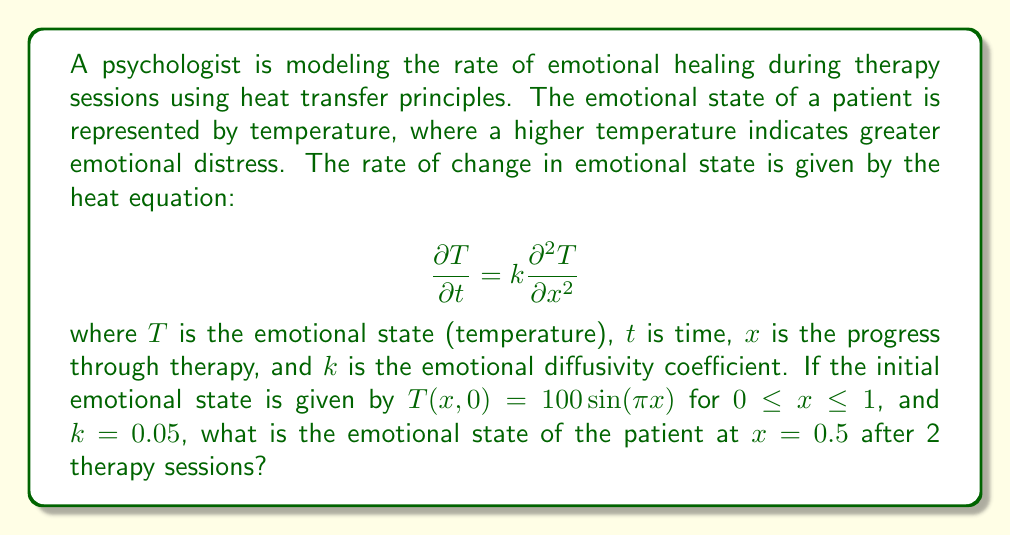Teach me how to tackle this problem. To solve this problem, we can use the separation of variables method for the heat equation:

1) The general solution to the heat equation with the given initial condition is:

   $$T(x,t) = \sum_{n=1}^{\infty} B_n \sin(n\pi x)e^{-kn^2\pi^2t}$$

2) From the initial condition, we can see that only the first term (n=1) is non-zero:

   $$T(x,0) = 100\sin(\pi x)$$

3) Therefore, our solution simplifies to:

   $$T(x,t) = 100\sin(\pi x)e^{-k\pi^2t}$$

4) We're asked about the state at x = 0.5 after 2 sessions, so we plug in these values:

   $$T(0.5, 2) = 100\sin(\pi(0.5))e^{-0.05\pi^2(2)}$$

5) Simplify:
   
   $$T(0.5, 2) = 100 \cdot 1 \cdot e^{-0.1\pi^2}$$

6) Calculate:

   $$T(0.5, 2) = 100e^{-0.1\pi^2} \approx 37.0388$$

Thus, the emotional state (temperature) at x = 0.5 after 2 sessions is approximately 37.0388.
Answer: 37.0388 